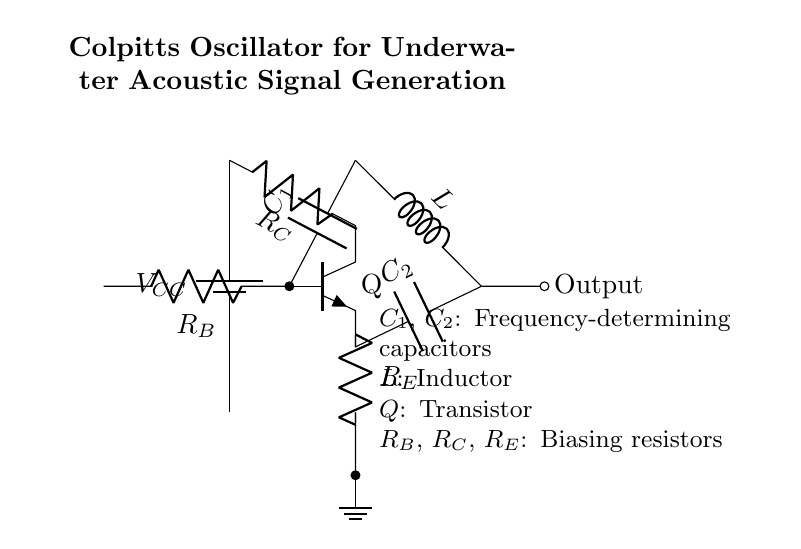What component is labeled as Q in the circuit? The label Q refers to a transistor, which is a common component in oscillators used for amplifying current. In this case, it acts as the active element in the Colpitts oscillator circuit.
Answer: Transistor What are the two frequency-determining capacitors in this circuit? The capacitors labeled as C1 and C2 are responsible for determining the frequency of oscillation in the Colpitts oscillator circuit. Their values impact the oscillation frequency along with the inductor L.
Answer: C1, C2 How many resistors are there in total in this circuit? There are three resistors: R_B, R_C, and R_E. These resistors are used to bias the transistor and help set its operating point in the circuit.
Answer: Three What type of oscillation does this circuit generate? The Colpitts oscillator is known for generating sine wave oscillations. This is a characteristic of its design, which includes feedback components that allow it to sustain oscillation without external input.
Answer: Sine wave How is the output taken from this circuit? The output is taken from the connection labeled as Output, which is located after the inductor L in the circuit configuration. This allows the generated signal to be accessed for further analysis or application in underwater acoustic signal generation.
Answer: Output 